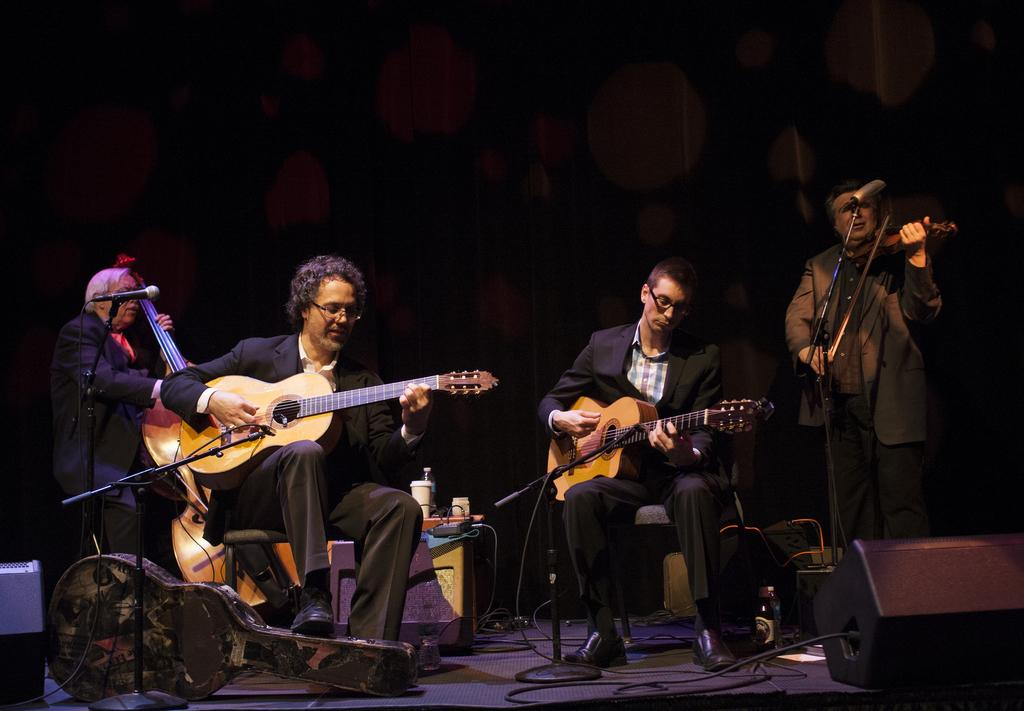How many people are in the image? There are four people in the image. What are the people doing in the image? The people are performing on a dais and playing musical instruments. What object is present to amplify their voices? A microphone is present in the image. What type of board can be seen being used by the performers in the image? There is no board present in the image; the performers are playing musical instruments and using a microphone. Can you tell me how many baskets are visible in the image? There are no baskets present in the image. 